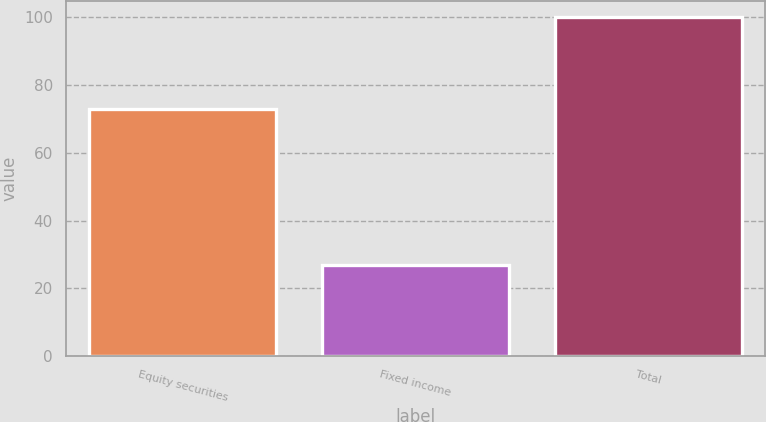Convert chart to OTSL. <chart><loc_0><loc_0><loc_500><loc_500><bar_chart><fcel>Equity securities<fcel>Fixed income<fcel>Total<nl><fcel>73<fcel>27<fcel>100<nl></chart> 